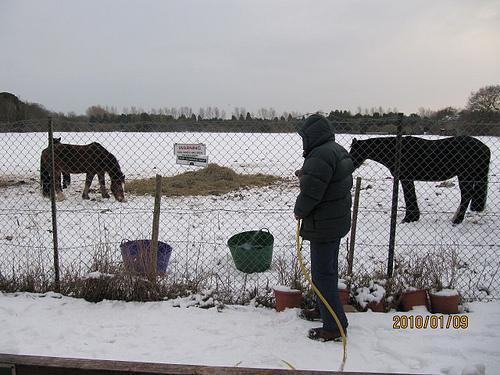How many different kinds of animals are in the photo?
Give a very brief answer. 1. How many people are in the photo?
Give a very brief answer. 1. How many horses can you see?
Give a very brief answer. 2. 